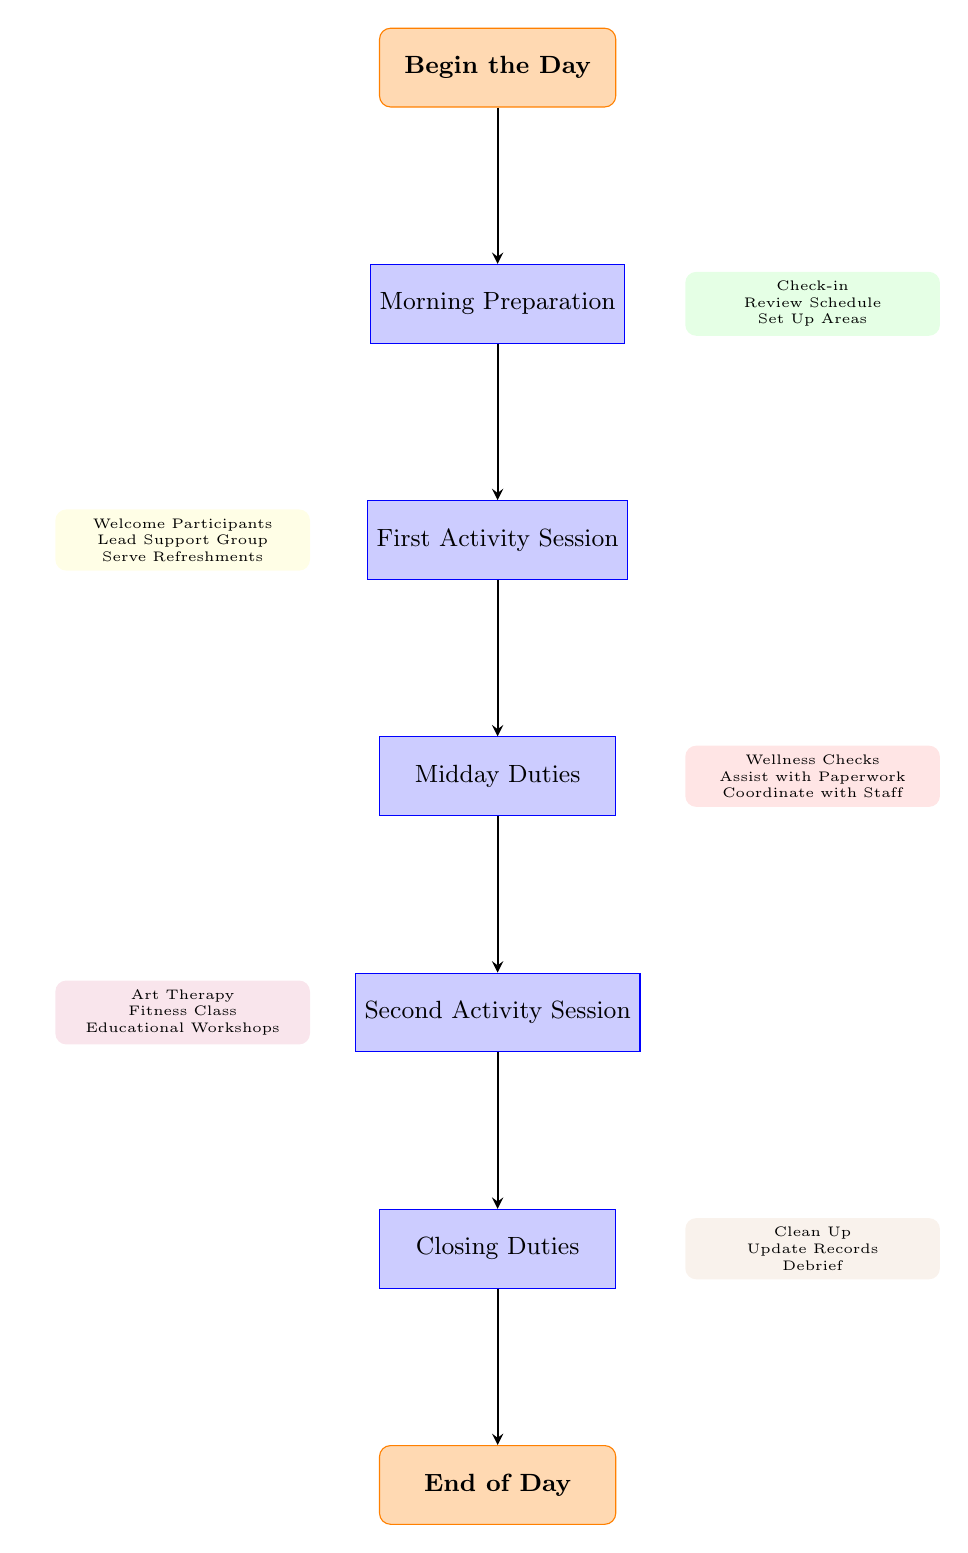What's the first task in the flow chart? The flow starts with "Begin the Day," and the first task listed directly below it is "Morning Preparation." This indicates the sequence of activities.
Answer: Morning Preparation What comes after "Midday Duties"? After "Midday Duties," there is an arrow pointing to the next task, which is "Second Activity Session," indicating the flow of tasks.
Answer: Second Activity Session How many main tasks are in the flow chart? The main tasks listed are Morning Preparation, First Activity Session, Midday Duties, Second Activity Session, and Closing Duties, which are five tasks in total.
Answer: Five Which task involves serving refreshments? "Serving refreshments" is part of the "First Activity Session," where it specifically mentions preparing and serving refreshments as a step.
Answer: First Activity Session What are the closing duties according to the flow chart? The closing duties consist of three steps: "Clean Up Activity Areas," "Update Records," and "Debrief with Supervisors." These steps collect tasks under the closing duties category.
Answer: Clean Up Activity Areas, Update Records, Debrief with Supervisors What does the arrow symbolize in this flow chart? The arrows in the flow chart represent the flow of tasks, indicating the order in which the volunteer activities should be performed throughout the day.
Answer: Flow of tasks How do the "First Activity Session" and "Midday Duties" relate in the chart? The "First Activity Session" leads into "Midday Duties," showing a direct progression from one task to another as part of the daily schedule.
Answer: Direct progression What is the last task in the flow chart? The flow chart ends with "End of Day," which is directly below the "Closing Duties," marking the conclusion of the day's activities.
Answer: End of Day 